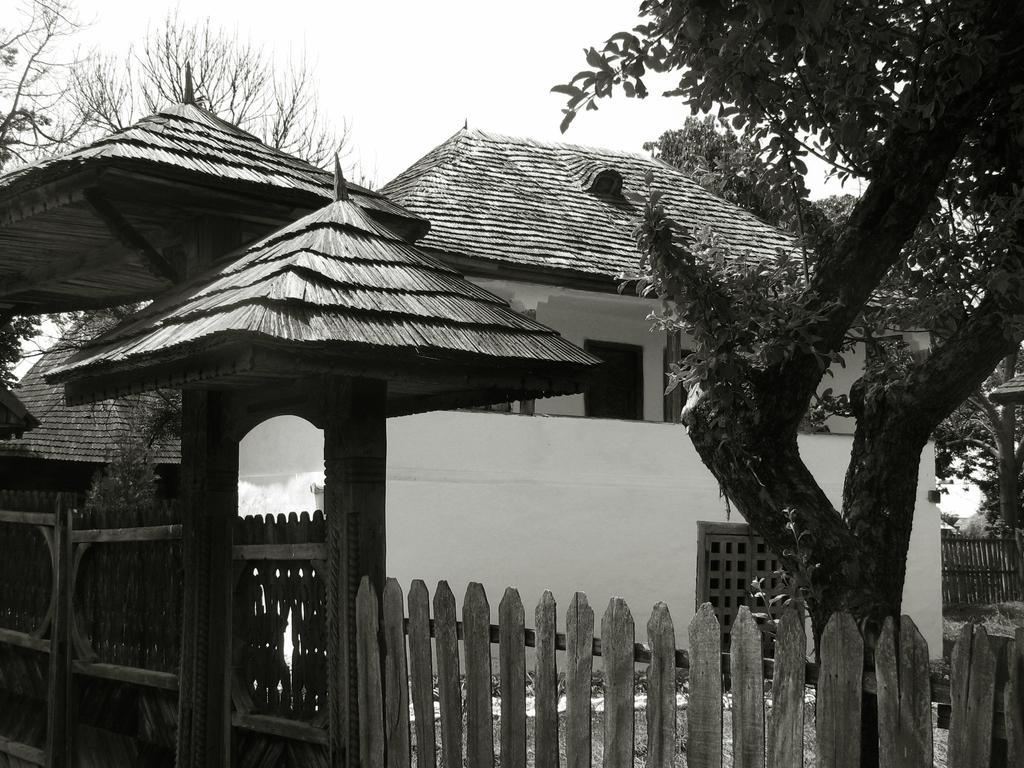Please provide a concise description of this image. As we can see in the image there are houses, trees, fence and on the top there is sky. 